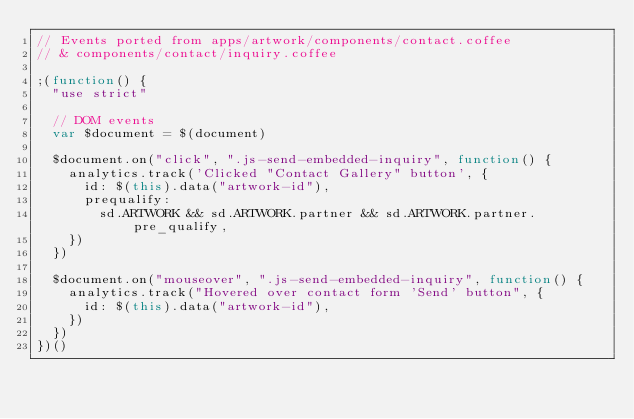Convert code to text. <code><loc_0><loc_0><loc_500><loc_500><_JavaScript_>// Events ported from apps/artwork/components/contact.coffee
// & components/contact/inquiry.coffee

;(function() {
  "use strict"

  // DOM events
  var $document = $(document)

  $document.on("click", ".js-send-embedded-inquiry", function() {
    analytics.track('Clicked "Contact Gallery" button', {
      id: $(this).data("artwork-id"),
      prequalify:
        sd.ARTWORK && sd.ARTWORK.partner && sd.ARTWORK.partner.pre_qualify,
    })
  })

  $document.on("mouseover", ".js-send-embedded-inquiry", function() {
    analytics.track("Hovered over contact form 'Send' button", {
      id: $(this).data("artwork-id"),
    })
  })
})()
</code> 